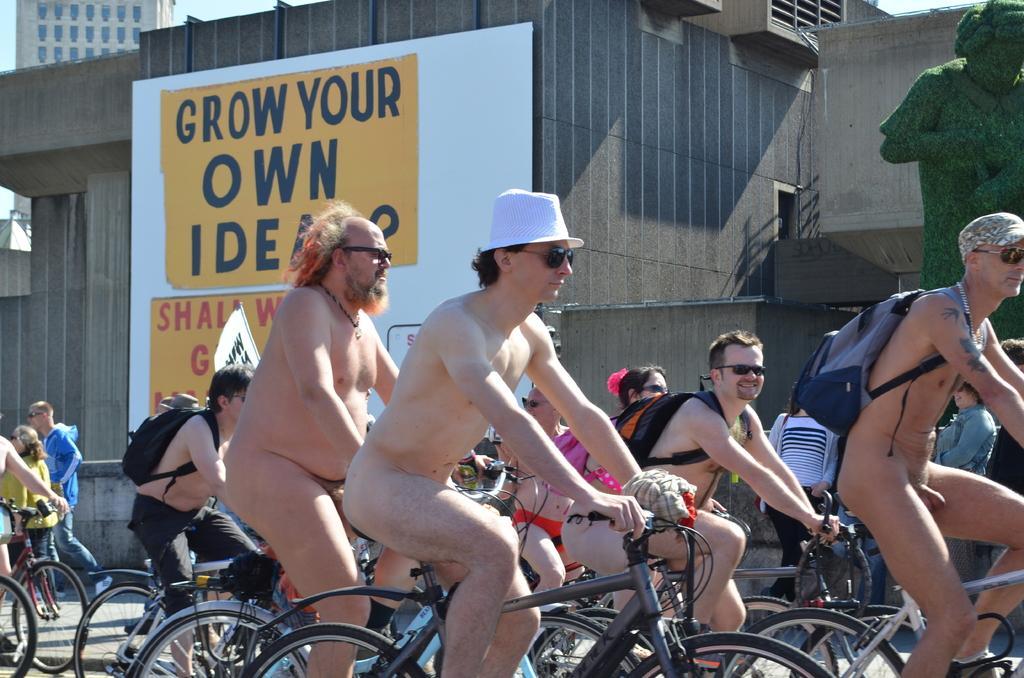Describe this image in one or two sentences. In this image there are group of people riding bicycle. At the back there are buildings and at the top there is a sky and at the right there is a statute and there is a hoarding at the back. 